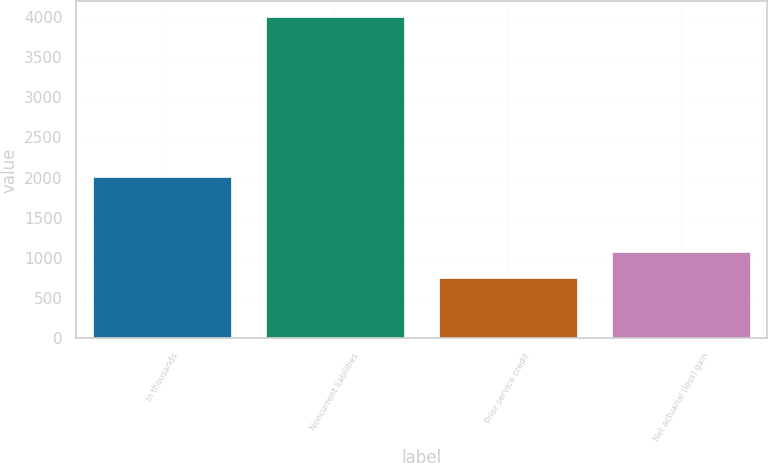Convert chart. <chart><loc_0><loc_0><loc_500><loc_500><bar_chart><fcel>In thousands<fcel>Noncurrent liabilities<fcel>Prior service credit<fcel>Net actuarial (loss) gain<nl><fcel>2010<fcel>3994<fcel>748<fcel>1072.6<nl></chart> 